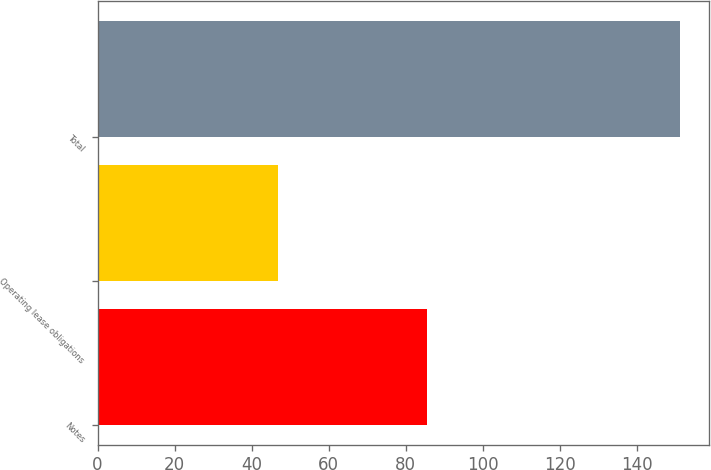Convert chart to OTSL. <chart><loc_0><loc_0><loc_500><loc_500><bar_chart><fcel>Notes<fcel>Operating lease obligations<fcel>Total<nl><fcel>85.5<fcel>46.8<fcel>151.1<nl></chart> 